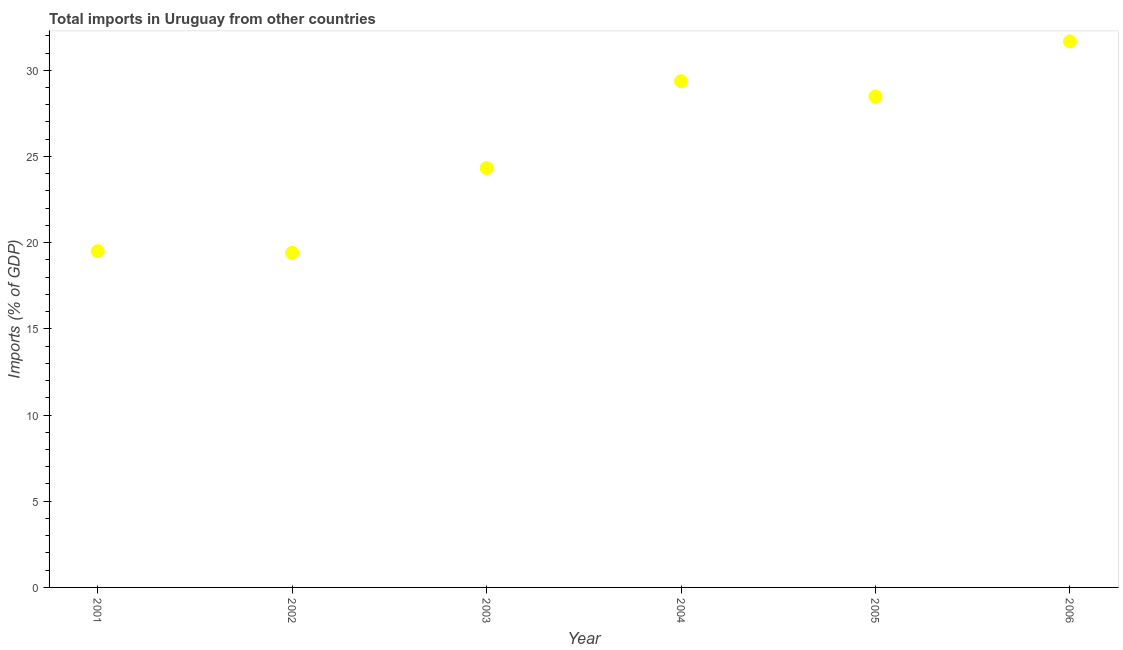What is the total imports in 2002?
Provide a succinct answer. 19.41. Across all years, what is the maximum total imports?
Provide a short and direct response. 31.67. Across all years, what is the minimum total imports?
Your answer should be compact. 19.41. In which year was the total imports maximum?
Make the answer very short. 2006. What is the sum of the total imports?
Offer a terse response. 152.75. What is the difference between the total imports in 2001 and 2003?
Offer a terse response. -4.82. What is the average total imports per year?
Provide a short and direct response. 25.46. What is the median total imports?
Your answer should be very brief. 26.4. What is the ratio of the total imports in 2003 to that in 2006?
Provide a short and direct response. 0.77. Is the total imports in 2001 less than that in 2002?
Offer a terse response. No. What is the difference between the highest and the second highest total imports?
Your answer should be compact. 2.31. What is the difference between the highest and the lowest total imports?
Keep it short and to the point. 12.27. How many years are there in the graph?
Give a very brief answer. 6. Does the graph contain any zero values?
Ensure brevity in your answer.  No. Does the graph contain grids?
Provide a short and direct response. No. What is the title of the graph?
Make the answer very short. Total imports in Uruguay from other countries. What is the label or title of the X-axis?
Keep it short and to the point. Year. What is the label or title of the Y-axis?
Provide a short and direct response. Imports (% of GDP). What is the Imports (% of GDP) in 2001?
Your response must be concise. 19.5. What is the Imports (% of GDP) in 2002?
Keep it short and to the point. 19.41. What is the Imports (% of GDP) in 2003?
Your response must be concise. 24.33. What is the Imports (% of GDP) in 2004?
Ensure brevity in your answer.  29.36. What is the Imports (% of GDP) in 2005?
Ensure brevity in your answer.  28.47. What is the Imports (% of GDP) in 2006?
Provide a short and direct response. 31.67. What is the difference between the Imports (% of GDP) in 2001 and 2002?
Provide a short and direct response. 0.1. What is the difference between the Imports (% of GDP) in 2001 and 2003?
Offer a terse response. -4.82. What is the difference between the Imports (% of GDP) in 2001 and 2004?
Your answer should be very brief. -9.86. What is the difference between the Imports (% of GDP) in 2001 and 2005?
Provide a short and direct response. -8.97. What is the difference between the Imports (% of GDP) in 2001 and 2006?
Offer a very short reply. -12.17. What is the difference between the Imports (% of GDP) in 2002 and 2003?
Keep it short and to the point. -4.92. What is the difference between the Imports (% of GDP) in 2002 and 2004?
Your answer should be compact. -9.96. What is the difference between the Imports (% of GDP) in 2002 and 2005?
Your answer should be compact. -9.07. What is the difference between the Imports (% of GDP) in 2002 and 2006?
Offer a terse response. -12.27. What is the difference between the Imports (% of GDP) in 2003 and 2004?
Provide a short and direct response. -5.04. What is the difference between the Imports (% of GDP) in 2003 and 2005?
Give a very brief answer. -4.15. What is the difference between the Imports (% of GDP) in 2003 and 2006?
Offer a very short reply. -7.35. What is the difference between the Imports (% of GDP) in 2004 and 2005?
Ensure brevity in your answer.  0.89. What is the difference between the Imports (% of GDP) in 2004 and 2006?
Your answer should be compact. -2.31. What is the difference between the Imports (% of GDP) in 2005 and 2006?
Offer a very short reply. -3.2. What is the ratio of the Imports (% of GDP) in 2001 to that in 2002?
Make the answer very short. 1. What is the ratio of the Imports (% of GDP) in 2001 to that in 2003?
Offer a very short reply. 0.8. What is the ratio of the Imports (% of GDP) in 2001 to that in 2004?
Offer a terse response. 0.66. What is the ratio of the Imports (% of GDP) in 2001 to that in 2005?
Keep it short and to the point. 0.69. What is the ratio of the Imports (% of GDP) in 2001 to that in 2006?
Ensure brevity in your answer.  0.62. What is the ratio of the Imports (% of GDP) in 2002 to that in 2003?
Offer a very short reply. 0.8. What is the ratio of the Imports (% of GDP) in 2002 to that in 2004?
Give a very brief answer. 0.66. What is the ratio of the Imports (% of GDP) in 2002 to that in 2005?
Offer a very short reply. 0.68. What is the ratio of the Imports (% of GDP) in 2002 to that in 2006?
Offer a terse response. 0.61. What is the ratio of the Imports (% of GDP) in 2003 to that in 2004?
Offer a terse response. 0.83. What is the ratio of the Imports (% of GDP) in 2003 to that in 2005?
Ensure brevity in your answer.  0.85. What is the ratio of the Imports (% of GDP) in 2003 to that in 2006?
Provide a short and direct response. 0.77. What is the ratio of the Imports (% of GDP) in 2004 to that in 2005?
Ensure brevity in your answer.  1.03. What is the ratio of the Imports (% of GDP) in 2004 to that in 2006?
Provide a short and direct response. 0.93. What is the ratio of the Imports (% of GDP) in 2005 to that in 2006?
Ensure brevity in your answer.  0.9. 